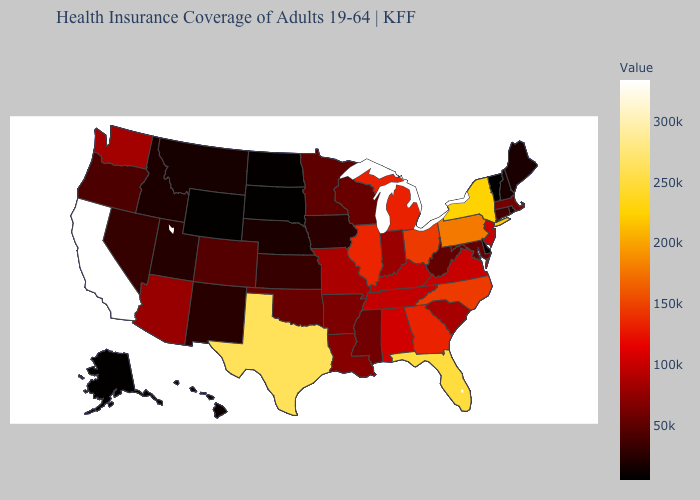Does Ohio have the highest value in the MidWest?
Answer briefly. Yes. Is the legend a continuous bar?
Be succinct. Yes. Does California have the highest value in the USA?
Quick response, please. Yes. Which states hav the highest value in the Northeast?
Keep it brief. New York. Which states hav the highest value in the South?
Quick response, please. Texas. 